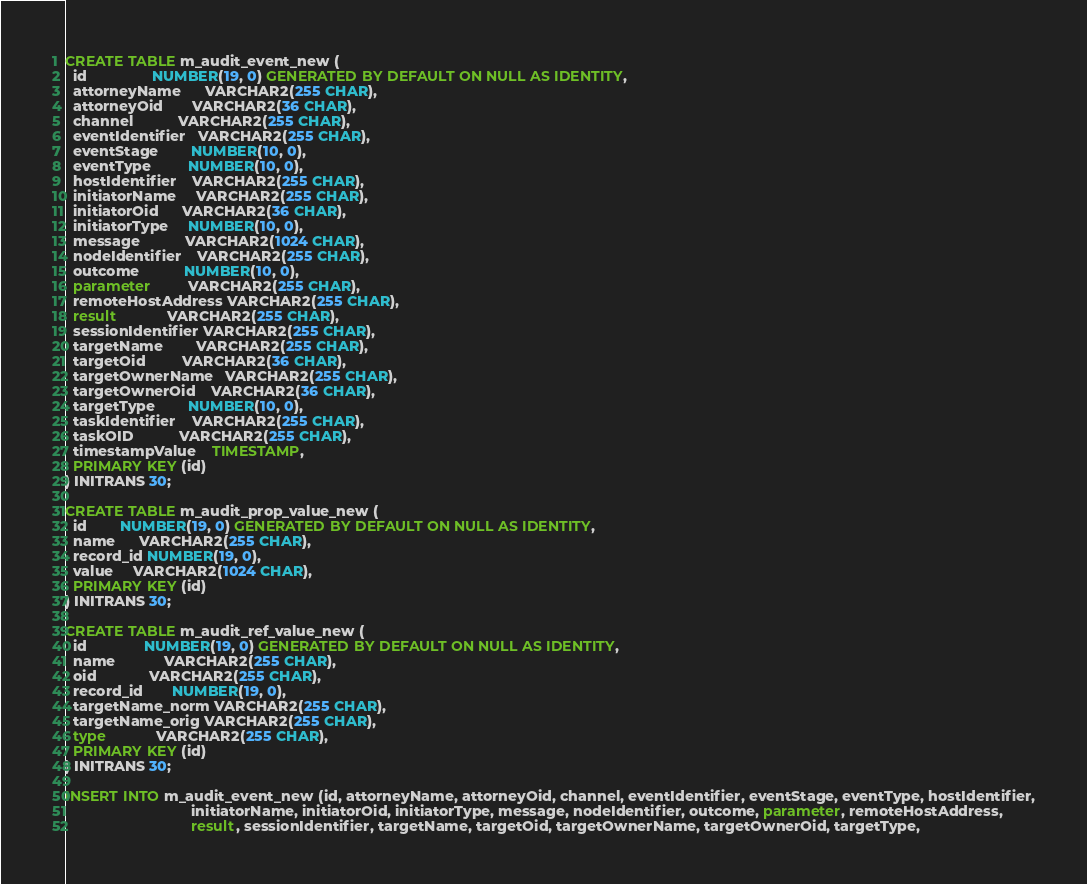Convert code to text. <code><loc_0><loc_0><loc_500><loc_500><_SQL_>CREATE TABLE m_audit_event_new (
  id                NUMBER(19, 0) GENERATED BY DEFAULT ON NULL AS IDENTITY,
  attorneyName      VARCHAR2(255 CHAR),
  attorneyOid       VARCHAR2(36 CHAR),
  channel           VARCHAR2(255 CHAR),
  eventIdentifier   VARCHAR2(255 CHAR),
  eventStage        NUMBER(10, 0),
  eventType         NUMBER(10, 0),
  hostIdentifier    VARCHAR2(255 CHAR),
  initiatorName     VARCHAR2(255 CHAR),
  initiatorOid      VARCHAR2(36 CHAR),
  initiatorType     NUMBER(10, 0),
  message           VARCHAR2(1024 CHAR),
  nodeIdentifier    VARCHAR2(255 CHAR),
  outcome           NUMBER(10, 0),
  parameter         VARCHAR2(255 CHAR),
  remoteHostAddress VARCHAR2(255 CHAR),
  result            VARCHAR2(255 CHAR),
  sessionIdentifier VARCHAR2(255 CHAR),
  targetName        VARCHAR2(255 CHAR),
  targetOid         VARCHAR2(36 CHAR),
  targetOwnerName   VARCHAR2(255 CHAR),
  targetOwnerOid    VARCHAR2(36 CHAR),
  targetType        NUMBER(10, 0),
  taskIdentifier    VARCHAR2(255 CHAR),
  taskOID           VARCHAR2(255 CHAR),
  timestampValue    TIMESTAMP,
  PRIMARY KEY (id)
) INITRANS 30;

CREATE TABLE m_audit_prop_value_new (
  id        NUMBER(19, 0) GENERATED BY DEFAULT ON NULL AS IDENTITY,
  name      VARCHAR2(255 CHAR),
  record_id NUMBER(19, 0),
  value     VARCHAR2(1024 CHAR),
  PRIMARY KEY (id)
) INITRANS 30;

CREATE TABLE m_audit_ref_value_new (
  id              NUMBER(19, 0) GENERATED BY DEFAULT ON NULL AS IDENTITY,
  name            VARCHAR2(255 CHAR),
  oid             VARCHAR2(255 CHAR),
  record_id       NUMBER(19, 0),
  targetName_norm VARCHAR2(255 CHAR),
  targetName_orig VARCHAR2(255 CHAR),
  type            VARCHAR2(255 CHAR),
  PRIMARY KEY (id)
) INITRANS 30;

INSERT INTO m_audit_event_new (id, attorneyName, attorneyOid, channel, eventIdentifier, eventStage, eventType, hostIdentifier,
                               initiatorName, initiatorOid, initiatorType, message, nodeIdentifier, outcome, parameter, remoteHostAddress,
                               result, sessionIdentifier, targetName, targetOid, targetOwnerName, targetOwnerOid, targetType,</code> 